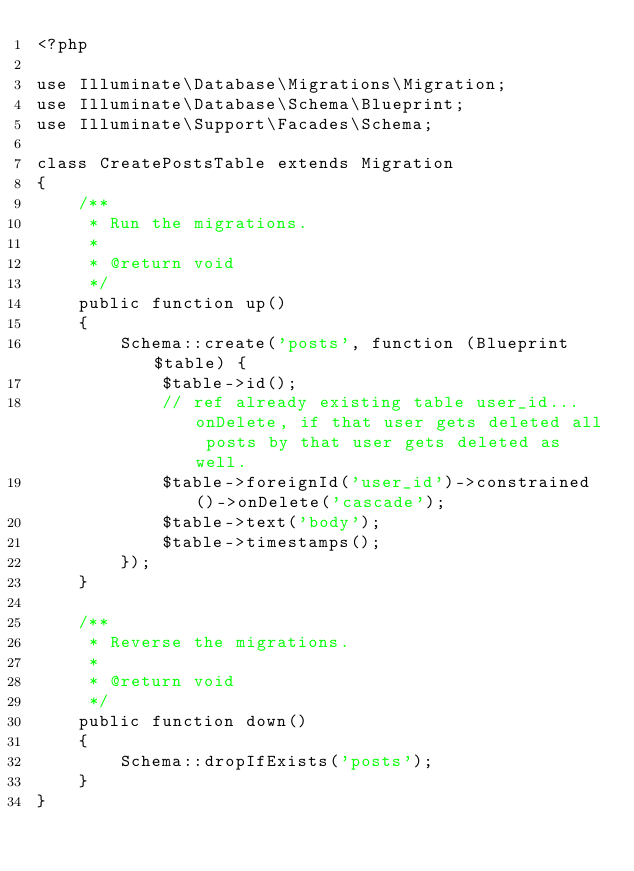Convert code to text. <code><loc_0><loc_0><loc_500><loc_500><_PHP_><?php

use Illuminate\Database\Migrations\Migration;
use Illuminate\Database\Schema\Blueprint;
use Illuminate\Support\Facades\Schema;

class CreatePostsTable extends Migration
{
    /**
     * Run the migrations.
     *
     * @return void
     */
    public function up()
    {
        Schema::create('posts', function (Blueprint $table) {
            $table->id();
            // ref already existing table user_id...onDelete, if that user gets deleted all posts by that user gets deleted as well.
            $table->foreignId('user_id')->constrained()->onDelete('cascade');
            $table->text('body');
            $table->timestamps();
        });
    }

    /**
     * Reverse the migrations.
     *
     * @return void
     */
    public function down()
    {
        Schema::dropIfExists('posts');
    }
}
</code> 